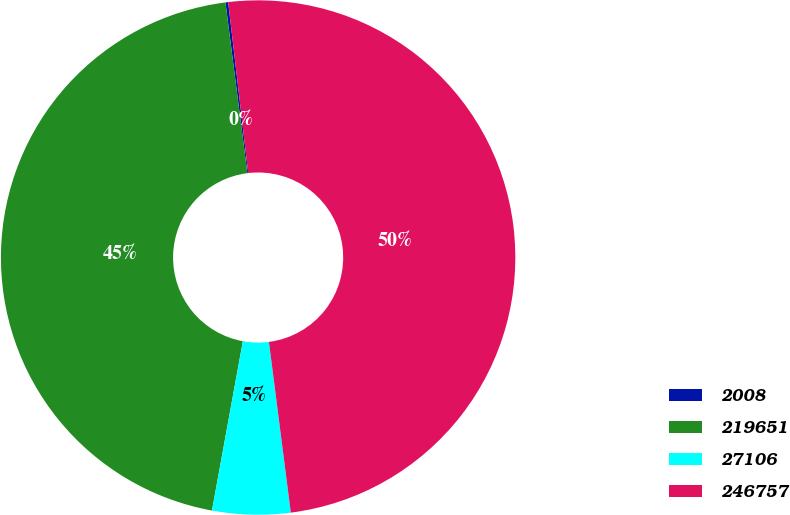<chart> <loc_0><loc_0><loc_500><loc_500><pie_chart><fcel>2008<fcel>219651<fcel>27106<fcel>246757<nl><fcel>0.17%<fcel>45.1%<fcel>4.9%<fcel>49.83%<nl></chart> 